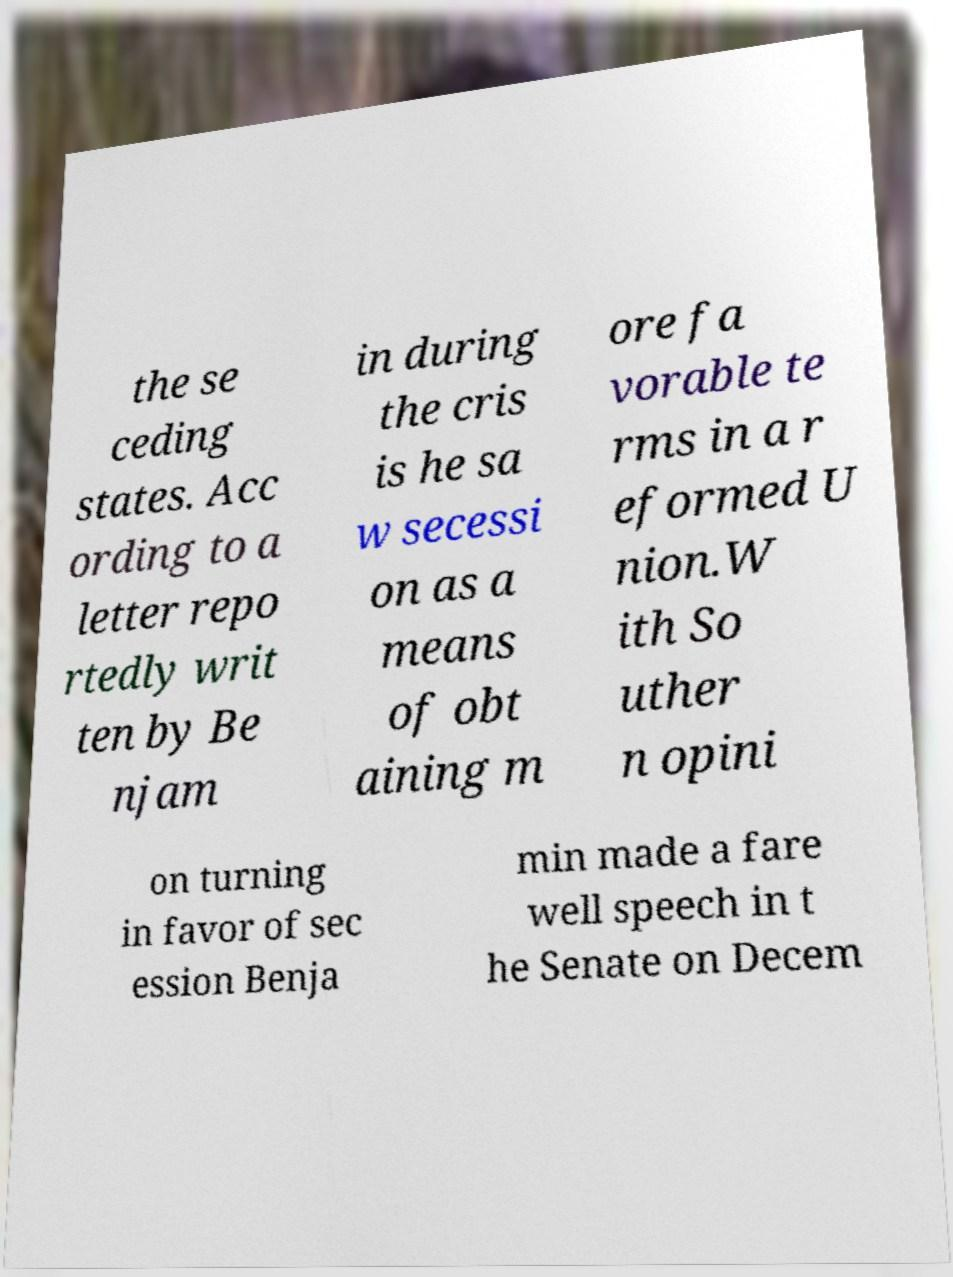I need the written content from this picture converted into text. Can you do that? the se ceding states. Acc ording to a letter repo rtedly writ ten by Be njam in during the cris is he sa w secessi on as a means of obt aining m ore fa vorable te rms in a r eformed U nion.W ith So uther n opini on turning in favor of sec ession Benja min made a fare well speech in t he Senate on Decem 